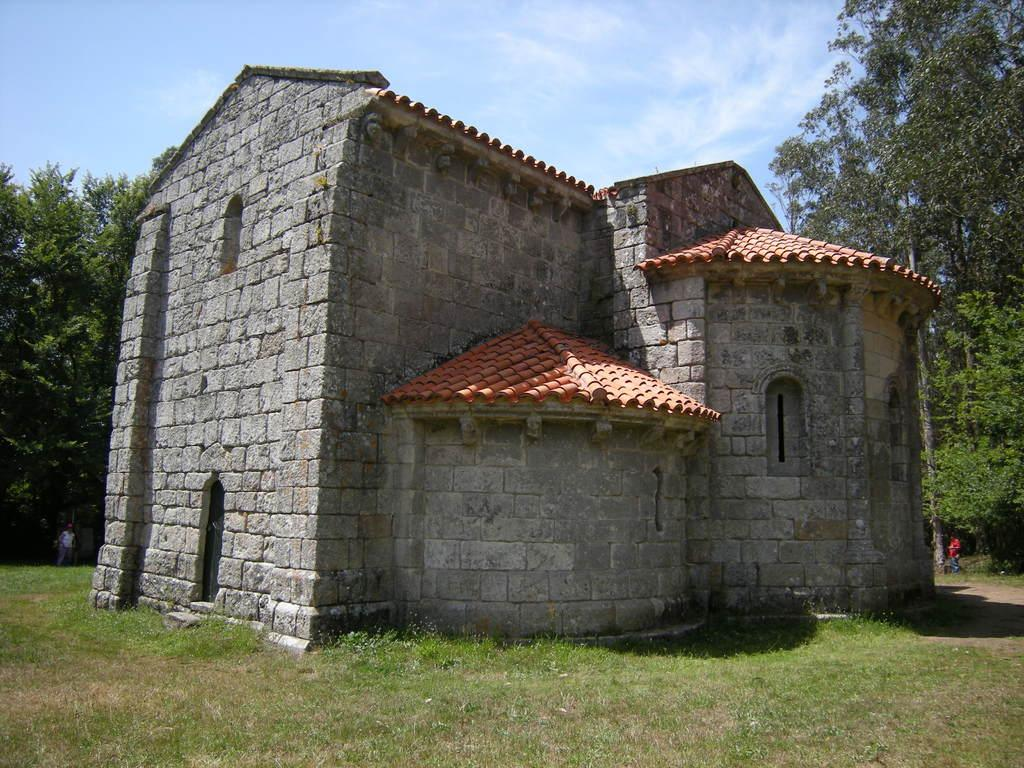What type of house is in the image? There is a stone house in the image. What is located near the house? There is a lawn in the image. Are there any living beings in the image? Yes, there are people present in the image. What other natural elements can be seen in the image? There are trees in the image. What is visible in the background of the image? The sky is visible in the background of the image, and clouds are present in the sky. How many babies are riding bikes on the route in the image? There are no babies, bikes, or routes present in the image. 